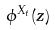Convert formula to latex. <formula><loc_0><loc_0><loc_500><loc_500>\phi ^ { X _ { t } } ( z )</formula> 